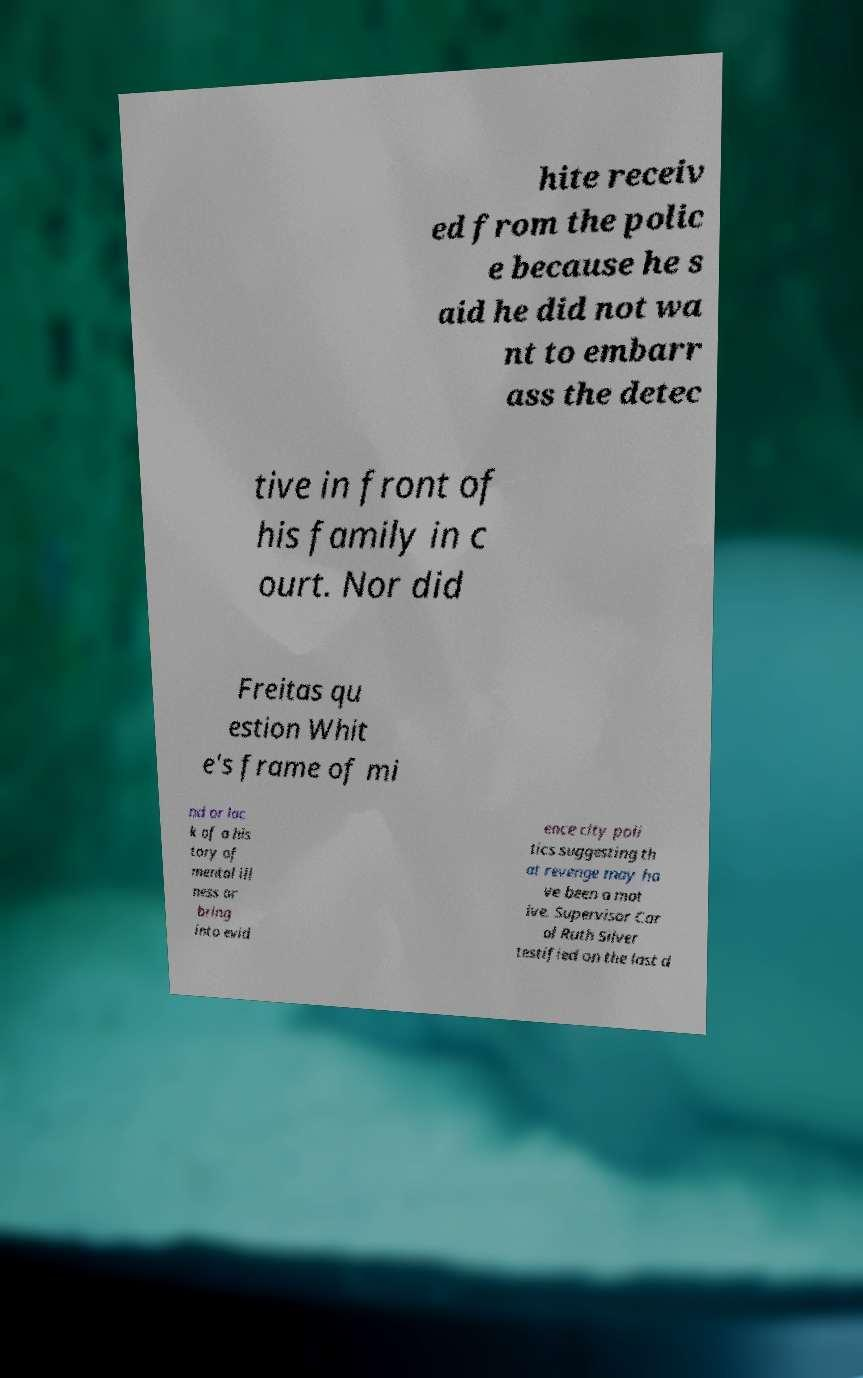I need the written content from this picture converted into text. Can you do that? hite receiv ed from the polic e because he s aid he did not wa nt to embarr ass the detec tive in front of his family in c ourt. Nor did Freitas qu estion Whit e's frame of mi nd or lac k of a his tory of mental ill ness or bring into evid ence city poli tics suggesting th at revenge may ha ve been a mot ive. Supervisor Car ol Ruth Silver testified on the last d 